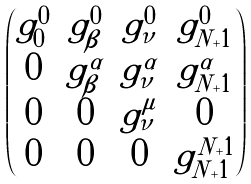Convert formula to latex. <formula><loc_0><loc_0><loc_500><loc_500>\begin{pmatrix} g ^ { 0 } _ { 0 } & g ^ { 0 } _ { \beta } & g ^ { 0 } _ { \nu } & g ^ { 0 } _ { N + 1 } \\ 0 & g ^ { \alpha } _ { \beta } & g ^ { \alpha } _ { \nu } & g ^ { \alpha } _ { N + 1 } \\ 0 & 0 & g ^ { \mu } _ { \nu } & 0 \\ 0 & 0 & 0 & g ^ { N + 1 } _ { N + 1 } \end{pmatrix}</formula> 